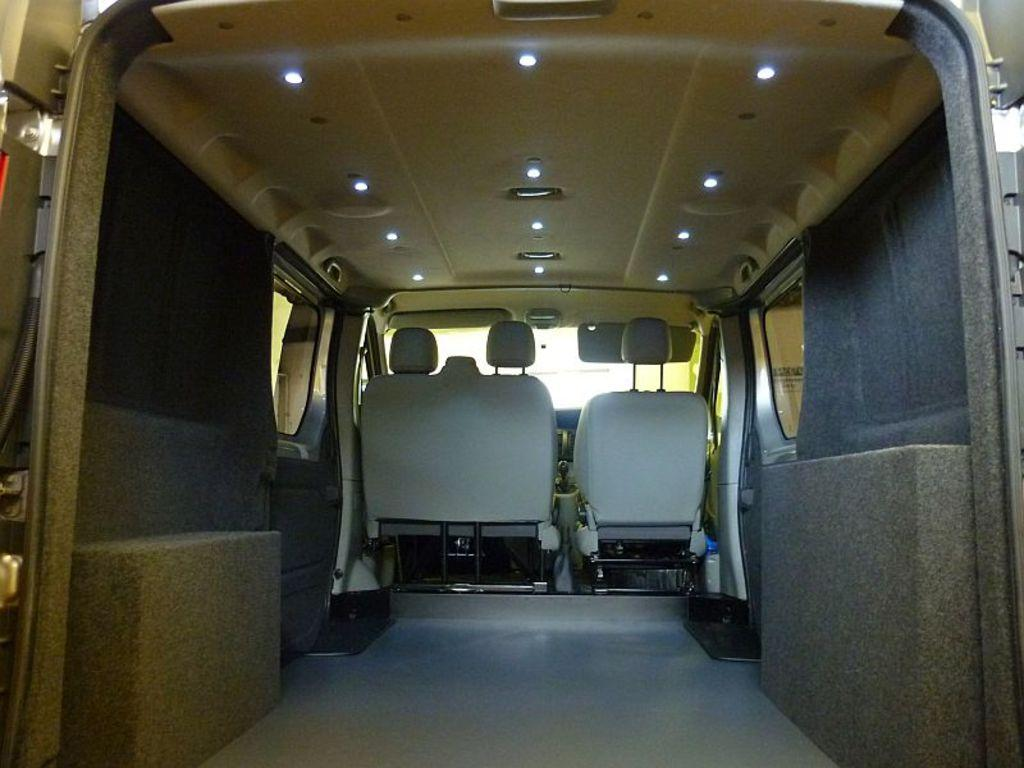What type of vehicle is in the image? The vehicle appears to be a van. What can be found inside the vehicle? The vehicle has seats in white color. Are there any additional features visible on the vehicle? Yes, the vehicle has lights at the top. What type of chain can be seen hanging from the air in the image? There is no chain present in the image. How does the air affect the movement of the vehicle in the image? The air does not affect the movement of the vehicle in the image; it is stationary. 